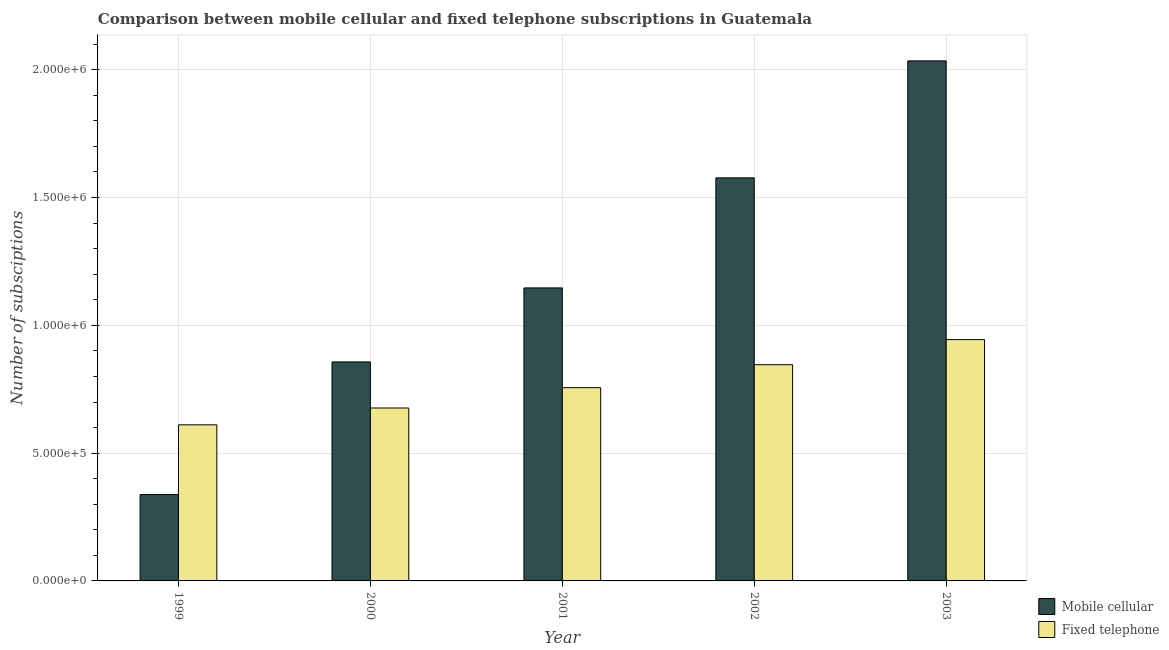Are the number of bars per tick equal to the number of legend labels?
Your answer should be very brief. Yes. Are the number of bars on each tick of the X-axis equal?
Your answer should be compact. Yes. How many bars are there on the 4th tick from the left?
Your answer should be very brief. 2. How many bars are there on the 1st tick from the right?
Offer a very short reply. 2. What is the label of the 3rd group of bars from the left?
Provide a short and direct response. 2001. What is the number of fixed telephone subscriptions in 2002?
Provide a succinct answer. 8.46e+05. Across all years, what is the maximum number of fixed telephone subscriptions?
Keep it short and to the point. 9.44e+05. Across all years, what is the minimum number of fixed telephone subscriptions?
Your response must be concise. 6.11e+05. In which year was the number of fixed telephone subscriptions maximum?
Provide a short and direct response. 2003. In which year was the number of fixed telephone subscriptions minimum?
Offer a terse response. 1999. What is the total number of mobile cellular subscriptions in the graph?
Provide a short and direct response. 5.95e+06. What is the difference between the number of mobile cellular subscriptions in 1999 and that in 2003?
Make the answer very short. -1.70e+06. What is the difference between the number of fixed telephone subscriptions in 2000 and the number of mobile cellular subscriptions in 2001?
Give a very brief answer. -7.95e+04. What is the average number of fixed telephone subscriptions per year?
Offer a terse response. 7.67e+05. In the year 2000, what is the difference between the number of fixed telephone subscriptions and number of mobile cellular subscriptions?
Provide a succinct answer. 0. In how many years, is the number of fixed telephone subscriptions greater than 1100000?
Your answer should be very brief. 0. What is the ratio of the number of mobile cellular subscriptions in 1999 to that in 2003?
Your response must be concise. 0.17. Is the number of mobile cellular subscriptions in 2000 less than that in 2003?
Your response must be concise. Yes. What is the difference between the highest and the second highest number of fixed telephone subscriptions?
Offer a terse response. 9.82e+04. What is the difference between the highest and the lowest number of fixed telephone subscriptions?
Offer a very short reply. 3.33e+05. What does the 1st bar from the left in 2001 represents?
Offer a terse response. Mobile cellular. What does the 2nd bar from the right in 1999 represents?
Your answer should be very brief. Mobile cellular. How many bars are there?
Keep it short and to the point. 10. How many years are there in the graph?
Make the answer very short. 5. What is the difference between two consecutive major ticks on the Y-axis?
Provide a short and direct response. 5.00e+05. Are the values on the major ticks of Y-axis written in scientific E-notation?
Keep it short and to the point. Yes. How are the legend labels stacked?
Keep it short and to the point. Vertical. What is the title of the graph?
Provide a succinct answer. Comparison between mobile cellular and fixed telephone subscriptions in Guatemala. Does "Under-five" appear as one of the legend labels in the graph?
Your answer should be very brief. No. What is the label or title of the Y-axis?
Offer a very short reply. Number of subsciptions. What is the Number of subsciptions in Mobile cellular in 1999?
Ensure brevity in your answer.  3.38e+05. What is the Number of subsciptions in Fixed telephone in 1999?
Your answer should be compact. 6.11e+05. What is the Number of subsciptions of Mobile cellular in 2000?
Provide a short and direct response. 8.57e+05. What is the Number of subsciptions in Fixed telephone in 2000?
Provide a succinct answer. 6.77e+05. What is the Number of subsciptions of Mobile cellular in 2001?
Your answer should be very brief. 1.15e+06. What is the Number of subsciptions in Fixed telephone in 2001?
Offer a very short reply. 7.56e+05. What is the Number of subsciptions of Mobile cellular in 2002?
Offer a terse response. 1.58e+06. What is the Number of subsciptions of Fixed telephone in 2002?
Ensure brevity in your answer.  8.46e+05. What is the Number of subsciptions of Mobile cellular in 2003?
Offer a terse response. 2.03e+06. What is the Number of subsciptions in Fixed telephone in 2003?
Ensure brevity in your answer.  9.44e+05. Across all years, what is the maximum Number of subsciptions in Mobile cellular?
Provide a succinct answer. 2.03e+06. Across all years, what is the maximum Number of subsciptions of Fixed telephone?
Provide a short and direct response. 9.44e+05. Across all years, what is the minimum Number of subsciptions in Mobile cellular?
Your response must be concise. 3.38e+05. Across all years, what is the minimum Number of subsciptions of Fixed telephone?
Provide a short and direct response. 6.11e+05. What is the total Number of subsciptions of Mobile cellular in the graph?
Your answer should be compact. 5.95e+06. What is the total Number of subsciptions of Fixed telephone in the graph?
Your response must be concise. 3.83e+06. What is the difference between the Number of subsciptions in Mobile cellular in 1999 and that in 2000?
Offer a very short reply. -5.19e+05. What is the difference between the Number of subsciptions of Fixed telephone in 1999 and that in 2000?
Make the answer very short. -6.59e+04. What is the difference between the Number of subsciptions in Mobile cellular in 1999 and that in 2001?
Provide a succinct answer. -8.09e+05. What is the difference between the Number of subsciptions of Fixed telephone in 1999 and that in 2001?
Your answer should be very brief. -1.45e+05. What is the difference between the Number of subsciptions of Mobile cellular in 1999 and that in 2002?
Your answer should be very brief. -1.24e+06. What is the difference between the Number of subsciptions of Fixed telephone in 1999 and that in 2002?
Provide a succinct answer. -2.35e+05. What is the difference between the Number of subsciptions of Mobile cellular in 1999 and that in 2003?
Provide a short and direct response. -1.70e+06. What is the difference between the Number of subsciptions in Fixed telephone in 1999 and that in 2003?
Offer a very short reply. -3.33e+05. What is the difference between the Number of subsciptions of Mobile cellular in 2000 and that in 2001?
Offer a very short reply. -2.90e+05. What is the difference between the Number of subsciptions in Fixed telephone in 2000 and that in 2001?
Give a very brief answer. -7.95e+04. What is the difference between the Number of subsciptions in Mobile cellular in 2000 and that in 2002?
Provide a succinct answer. -7.20e+05. What is the difference between the Number of subsciptions of Fixed telephone in 2000 and that in 2002?
Keep it short and to the point. -1.69e+05. What is the difference between the Number of subsciptions in Mobile cellular in 2000 and that in 2003?
Provide a succinct answer. -1.18e+06. What is the difference between the Number of subsciptions of Fixed telephone in 2000 and that in 2003?
Make the answer very short. -2.68e+05. What is the difference between the Number of subsciptions in Mobile cellular in 2001 and that in 2002?
Your answer should be very brief. -4.31e+05. What is the difference between the Number of subsciptions of Fixed telephone in 2001 and that in 2002?
Offer a very short reply. -8.99e+04. What is the difference between the Number of subsciptions in Mobile cellular in 2001 and that in 2003?
Ensure brevity in your answer.  -8.88e+05. What is the difference between the Number of subsciptions of Fixed telephone in 2001 and that in 2003?
Offer a terse response. -1.88e+05. What is the difference between the Number of subsciptions of Mobile cellular in 2002 and that in 2003?
Provide a succinct answer. -4.58e+05. What is the difference between the Number of subsciptions in Fixed telephone in 2002 and that in 2003?
Offer a terse response. -9.82e+04. What is the difference between the Number of subsciptions in Mobile cellular in 1999 and the Number of subsciptions in Fixed telephone in 2000?
Ensure brevity in your answer.  -3.39e+05. What is the difference between the Number of subsciptions in Mobile cellular in 1999 and the Number of subsciptions in Fixed telephone in 2001?
Keep it short and to the point. -4.18e+05. What is the difference between the Number of subsciptions of Mobile cellular in 1999 and the Number of subsciptions of Fixed telephone in 2002?
Your response must be concise. -5.08e+05. What is the difference between the Number of subsciptions in Mobile cellular in 1999 and the Number of subsciptions in Fixed telephone in 2003?
Offer a very short reply. -6.06e+05. What is the difference between the Number of subsciptions in Mobile cellular in 2000 and the Number of subsciptions in Fixed telephone in 2001?
Give a very brief answer. 1.01e+05. What is the difference between the Number of subsciptions of Mobile cellular in 2000 and the Number of subsciptions of Fixed telephone in 2002?
Offer a very short reply. 1.09e+04. What is the difference between the Number of subsciptions of Mobile cellular in 2000 and the Number of subsciptions of Fixed telephone in 2003?
Offer a very short reply. -8.73e+04. What is the difference between the Number of subsciptions of Mobile cellular in 2001 and the Number of subsciptions of Fixed telephone in 2002?
Make the answer very short. 3.00e+05. What is the difference between the Number of subsciptions of Mobile cellular in 2001 and the Number of subsciptions of Fixed telephone in 2003?
Offer a very short reply. 2.02e+05. What is the difference between the Number of subsciptions of Mobile cellular in 2002 and the Number of subsciptions of Fixed telephone in 2003?
Your answer should be compact. 6.33e+05. What is the average Number of subsciptions in Mobile cellular per year?
Provide a succinct answer. 1.19e+06. What is the average Number of subsciptions in Fixed telephone per year?
Provide a short and direct response. 7.67e+05. In the year 1999, what is the difference between the Number of subsciptions in Mobile cellular and Number of subsciptions in Fixed telephone?
Give a very brief answer. -2.73e+05. In the year 2000, what is the difference between the Number of subsciptions of Mobile cellular and Number of subsciptions of Fixed telephone?
Your answer should be very brief. 1.80e+05. In the year 2001, what is the difference between the Number of subsciptions in Mobile cellular and Number of subsciptions in Fixed telephone?
Ensure brevity in your answer.  3.90e+05. In the year 2002, what is the difference between the Number of subsciptions of Mobile cellular and Number of subsciptions of Fixed telephone?
Keep it short and to the point. 7.31e+05. In the year 2003, what is the difference between the Number of subsciptions in Mobile cellular and Number of subsciptions in Fixed telephone?
Your answer should be compact. 1.09e+06. What is the ratio of the Number of subsciptions in Mobile cellular in 1999 to that in 2000?
Offer a terse response. 0.39. What is the ratio of the Number of subsciptions in Fixed telephone in 1999 to that in 2000?
Offer a very short reply. 0.9. What is the ratio of the Number of subsciptions of Mobile cellular in 1999 to that in 2001?
Your answer should be compact. 0.29. What is the ratio of the Number of subsciptions of Fixed telephone in 1999 to that in 2001?
Your answer should be very brief. 0.81. What is the ratio of the Number of subsciptions in Mobile cellular in 1999 to that in 2002?
Keep it short and to the point. 0.21. What is the ratio of the Number of subsciptions in Fixed telephone in 1999 to that in 2002?
Offer a terse response. 0.72. What is the ratio of the Number of subsciptions in Mobile cellular in 1999 to that in 2003?
Your answer should be compact. 0.17. What is the ratio of the Number of subsciptions in Fixed telephone in 1999 to that in 2003?
Your answer should be compact. 0.65. What is the ratio of the Number of subsciptions in Mobile cellular in 2000 to that in 2001?
Your answer should be very brief. 0.75. What is the ratio of the Number of subsciptions of Fixed telephone in 2000 to that in 2001?
Your response must be concise. 0.89. What is the ratio of the Number of subsciptions in Mobile cellular in 2000 to that in 2002?
Offer a terse response. 0.54. What is the ratio of the Number of subsciptions in Fixed telephone in 2000 to that in 2002?
Provide a succinct answer. 0.8. What is the ratio of the Number of subsciptions of Mobile cellular in 2000 to that in 2003?
Provide a succinct answer. 0.42. What is the ratio of the Number of subsciptions of Fixed telephone in 2000 to that in 2003?
Provide a short and direct response. 0.72. What is the ratio of the Number of subsciptions in Mobile cellular in 2001 to that in 2002?
Provide a short and direct response. 0.73. What is the ratio of the Number of subsciptions in Fixed telephone in 2001 to that in 2002?
Your answer should be very brief. 0.89. What is the ratio of the Number of subsciptions of Mobile cellular in 2001 to that in 2003?
Your response must be concise. 0.56. What is the ratio of the Number of subsciptions of Fixed telephone in 2001 to that in 2003?
Provide a short and direct response. 0.8. What is the ratio of the Number of subsciptions in Mobile cellular in 2002 to that in 2003?
Your response must be concise. 0.78. What is the ratio of the Number of subsciptions in Fixed telephone in 2002 to that in 2003?
Your response must be concise. 0.9. What is the difference between the highest and the second highest Number of subsciptions in Mobile cellular?
Your answer should be very brief. 4.58e+05. What is the difference between the highest and the second highest Number of subsciptions of Fixed telephone?
Make the answer very short. 9.82e+04. What is the difference between the highest and the lowest Number of subsciptions in Mobile cellular?
Provide a succinct answer. 1.70e+06. What is the difference between the highest and the lowest Number of subsciptions in Fixed telephone?
Provide a succinct answer. 3.33e+05. 